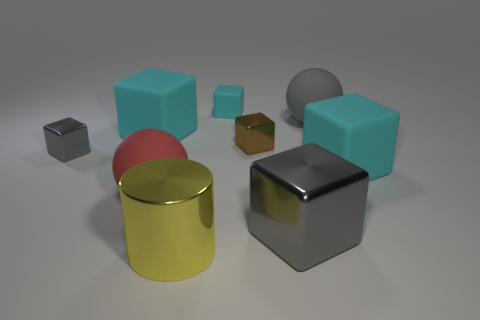Subtract all gray cubes. How many cubes are left? 4 Subtract all blue spheres. How many cyan cubes are left? 3 Subtract 1 cubes. How many cubes are left? 5 Subtract all brown blocks. How many blocks are left? 5 Subtract all blue cubes. Subtract all purple spheres. How many cubes are left? 6 Subtract all cylinders. How many objects are left? 8 Subtract 0 gray cylinders. How many objects are left? 9 Subtract all large gray balls. Subtract all tiny gray objects. How many objects are left? 7 Add 8 shiny cylinders. How many shiny cylinders are left? 9 Add 8 gray metallic blocks. How many gray metallic blocks exist? 10 